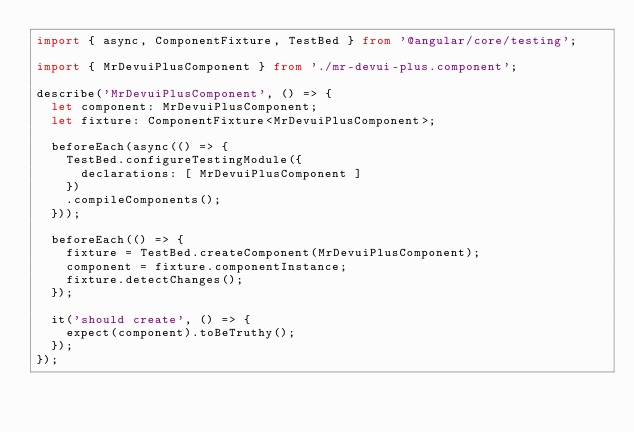Convert code to text. <code><loc_0><loc_0><loc_500><loc_500><_TypeScript_>import { async, ComponentFixture, TestBed } from '@angular/core/testing';

import { MrDevuiPlusComponent } from './mr-devui-plus.component';

describe('MrDevuiPlusComponent', () => {
  let component: MrDevuiPlusComponent;
  let fixture: ComponentFixture<MrDevuiPlusComponent>;

  beforeEach(async(() => {
    TestBed.configureTestingModule({
      declarations: [ MrDevuiPlusComponent ]
    })
    .compileComponents();
  }));

  beforeEach(() => {
    fixture = TestBed.createComponent(MrDevuiPlusComponent);
    component = fixture.componentInstance;
    fixture.detectChanges();
  });

  it('should create', () => {
    expect(component).toBeTruthy();
  });
});
</code> 